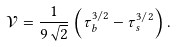<formula> <loc_0><loc_0><loc_500><loc_500>\mathcal { V } = \frac { 1 } { 9 \sqrt { 2 } } \left ( \tau _ { b } ^ { 3 / 2 } - \tau _ { s } ^ { 3 / 2 } \right ) .</formula> 